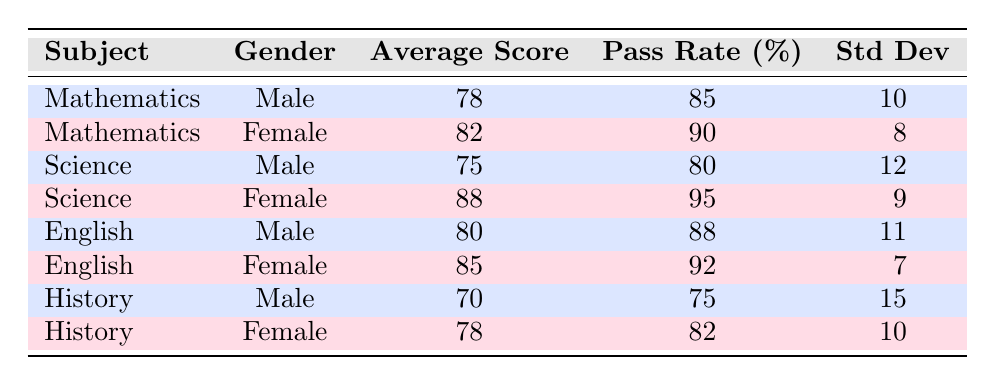What is the average score of male students in Mathematics? The table shows the average score for male students in Mathematics as 78.
Answer: 78 What is the pass rate for female students in Science? According to the table, the pass rate for female students in Science is 95.
Answer: 95 Which subject has the highest average score among female students? Looking at the average scores of female students, the highest score is 88 in Science.
Answer: Science Calculate the difference in average scores between male and female students in English. The average score for male students in English is 80, while for female students, it is 85. The difference is 85 - 80 = 5.
Answer: 5 Is the pass rate for male students in History greater than 75%? The pass rate for male students in History is 75%, so it is not greater than 75%.
Answer: No What is the combined average score of male students in Mathematics and Science? The average scores for male students are 78 (Mathematics) and 75 (Science). To find the combined average, we sum them (78 + 75) = 153 and divide by 2: 153 / 2 = 76.5.
Answer: 76.5 Do female students score higher on average than male students across all subjects? By examining the average scores, female students scored higher in Mathematics (82 vs 78), Science (88 vs 75), English (85 vs 80), and History (78 vs 70). Therefore, the statement is true.
Answer: Yes What is the standard deviation of female students' average scores in Science? The table lists the standard deviation for female students in Science as 9.
Answer: 9 